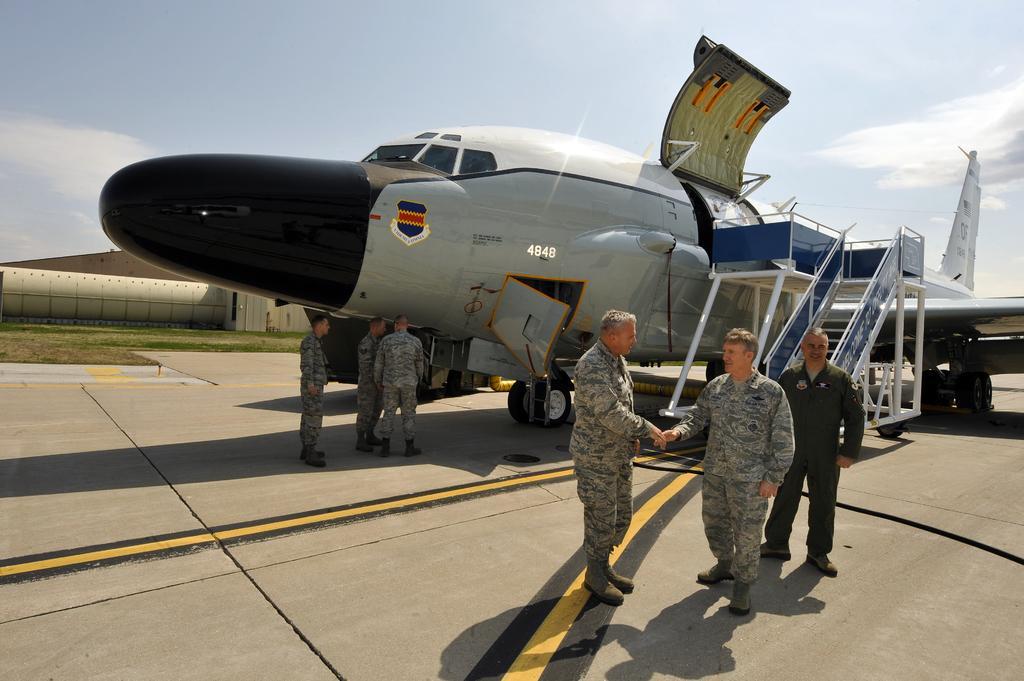Please provide a concise description of this image. In this image I can see the group of people standing on the road. These people are wearing the uniforms. To the side there is an aircraft which is in black and ash color. In the background I can see the clouds and the sky. 